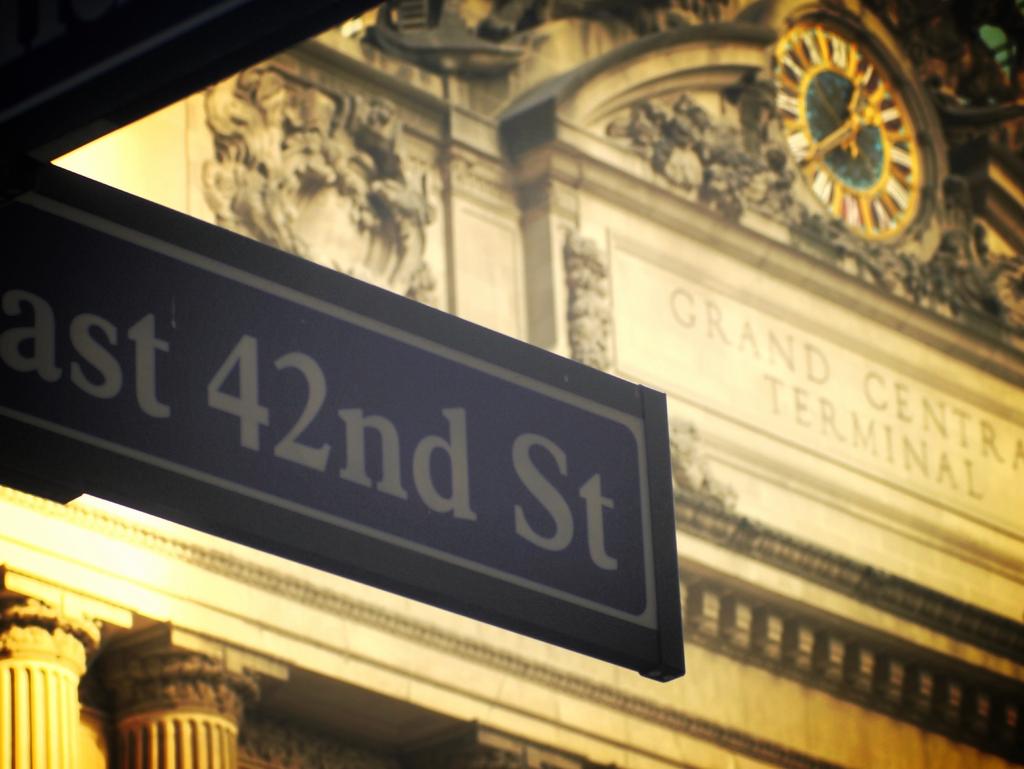What terminal is this?
Your answer should be compact. Grand central. This is street board address?
Offer a terse response. East 42nd st. 